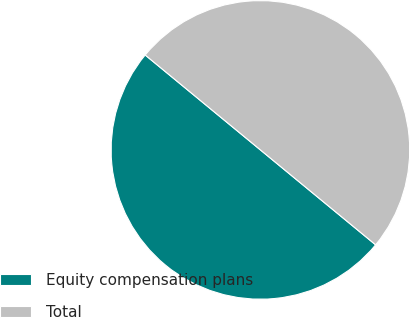Convert chart to OTSL. <chart><loc_0><loc_0><loc_500><loc_500><pie_chart><fcel>Equity compensation plans<fcel>Total<nl><fcel>50.0%<fcel>50.0%<nl></chart> 